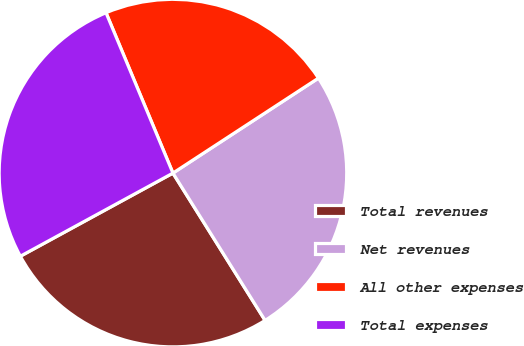Convert chart to OTSL. <chart><loc_0><loc_0><loc_500><loc_500><pie_chart><fcel>Total revenues<fcel>Net revenues<fcel>All other expenses<fcel>Total expenses<nl><fcel>25.96%<fcel>25.31%<fcel>22.09%<fcel>26.65%<nl></chart> 